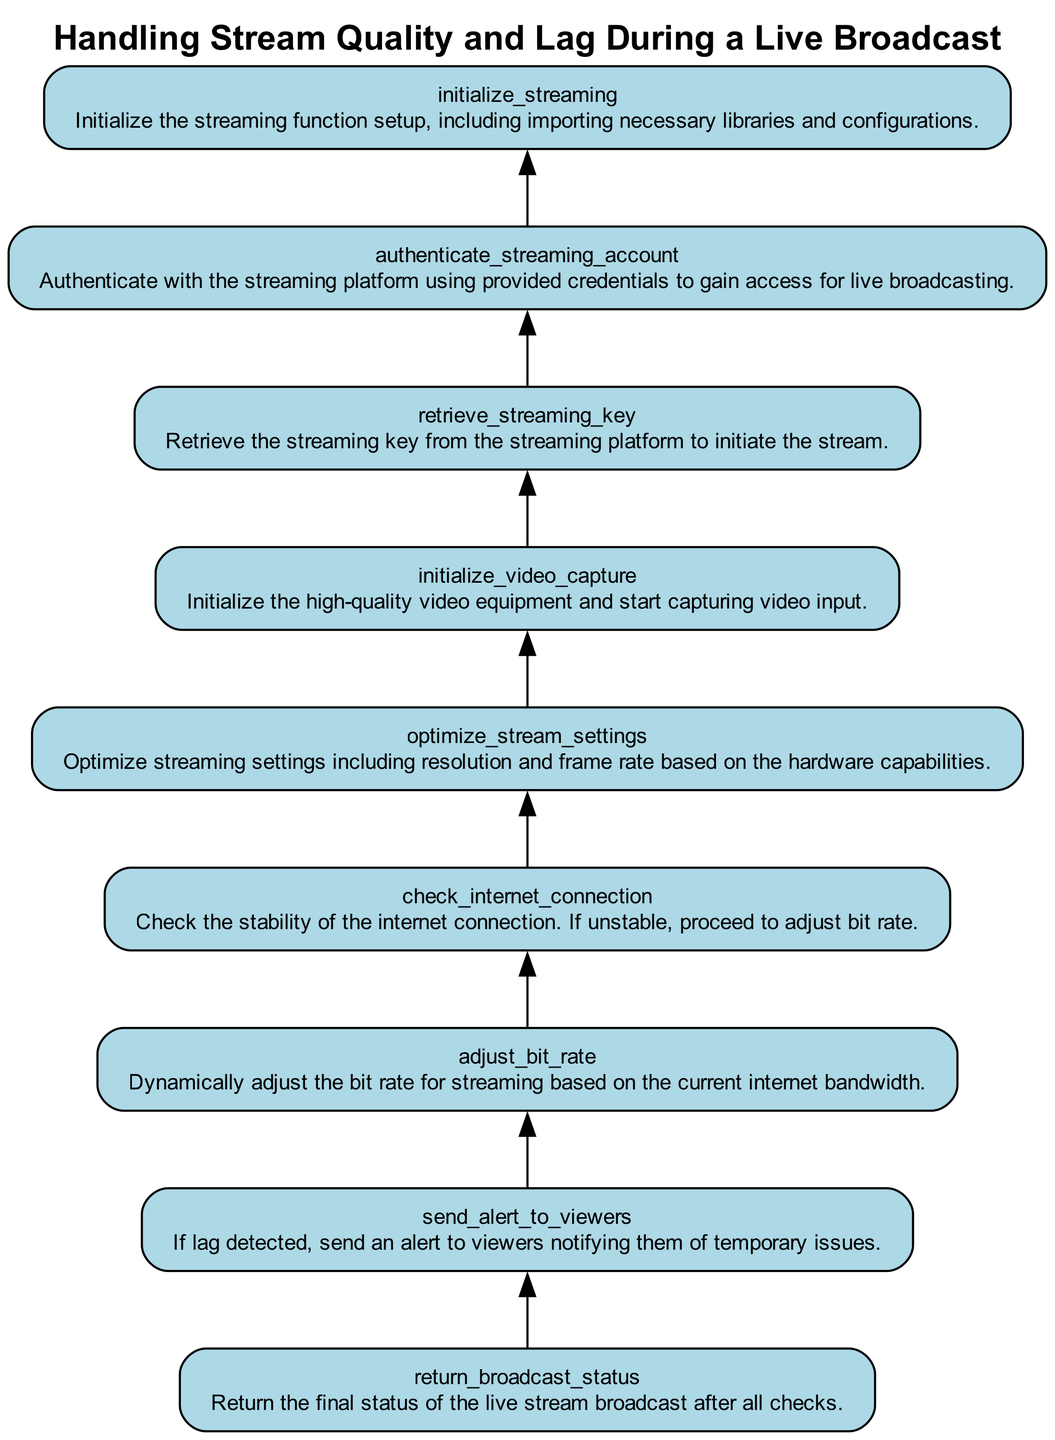What is the final step in the flowchart? The final step in the flowchart is denoted by the node 'return_broadcast_status', which indicates the end of the function's process for handling stream quality and lag during a live broadcast.
Answer: return broadcast status How many nodes are in the flowchart? There are a total of nine nodes in the flowchart, as each function step is represented by its own unique node.
Answer: nine Which step comes before 'send_alert_to_viewers'? The step that precedes 'send_alert_to_viewers' is 'adjust_bit_rate', which is indicated by its connection in the flow from the previous node to this one.
Answer: adjust bit rate What does the 'check_internet_connection' node do? The 'check_internet_connection' node checks the stability of the internet connection, and if unstable, it prompts further actions to adjust the bit rate for streaming.
Answer: checks internet connection If lag is detected, what action is taken? When lag is detected, the action taken is to 'send_alert_to_viewers', informing them of the temporary issues occurring with the stream.
Answer: send alert to viewers What is the purpose of the 'optimize_stream_settings' node? The 'optimize_stream_settings' node's purpose is to modify streaming settings, such as resolution and frame rate, based on the capabilities of the hardware being used for the broadcast.
Answer: optimize streaming settings In terms of flow, which node does 'initialize_video_capture' lead to? The 'initialize_video_capture' node leads to 'optimize_stream_settings', indicating that once video capture is started, the next step is to optimize the settings.
Answer: optimize stream settings What precedes the initialization of video capture? Before the initialization of video capture, the flowchart shows that the 'retrieve_streaming_key' must be completed, which is necessary to proceed with starting the video capturing process.
Answer: retrieve streaming key 